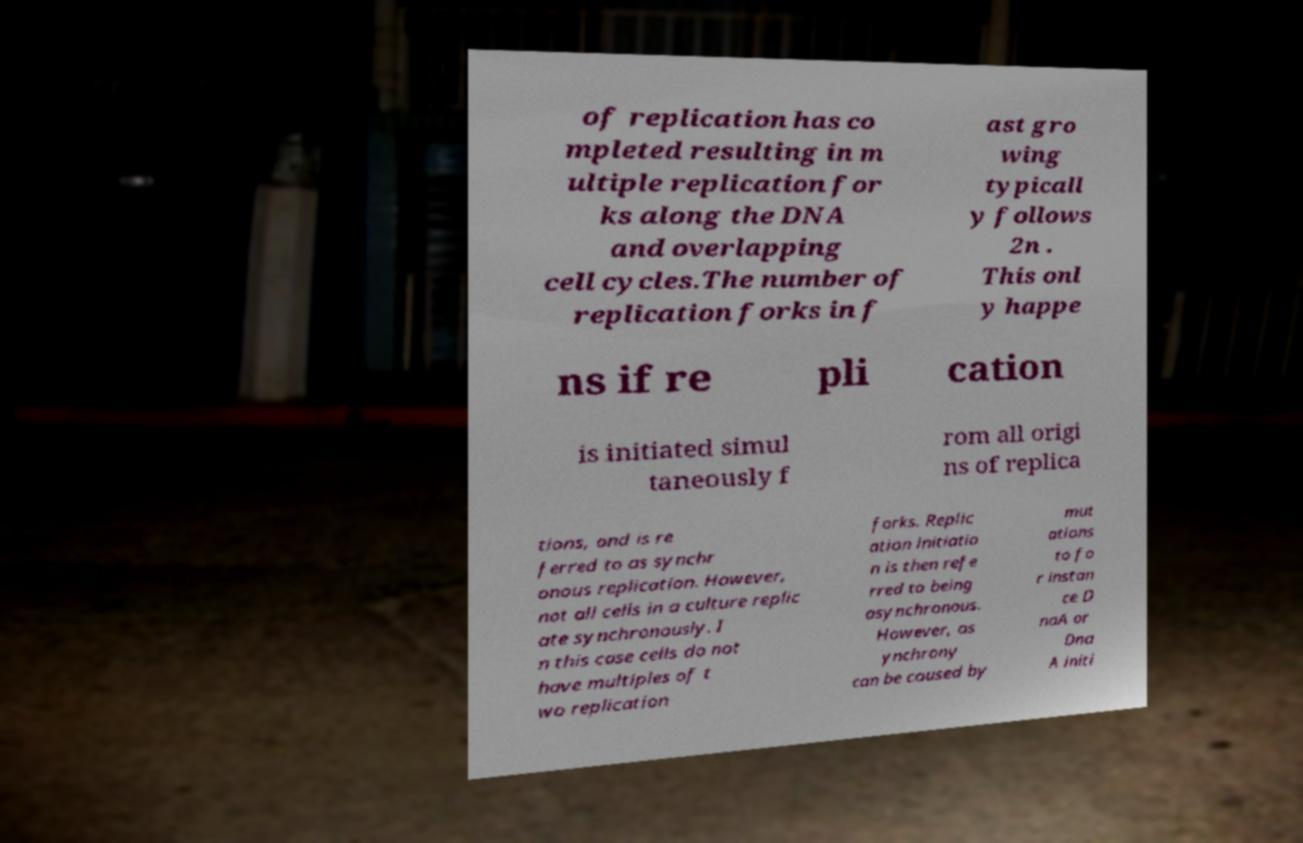Could you extract and type out the text from this image? of replication has co mpleted resulting in m ultiple replication for ks along the DNA and overlapping cell cycles.The number of replication forks in f ast gro wing typicall y follows 2n . This onl y happe ns if re pli cation is initiated simul taneously f rom all origi ns of replica tions, and is re ferred to as synchr onous replication. However, not all cells in a culture replic ate synchronously. I n this case cells do not have multiples of t wo replication forks. Replic ation initiatio n is then refe rred to being asynchronous. However, as ynchrony can be caused by mut ations to fo r instan ce D naA or Dna A initi 